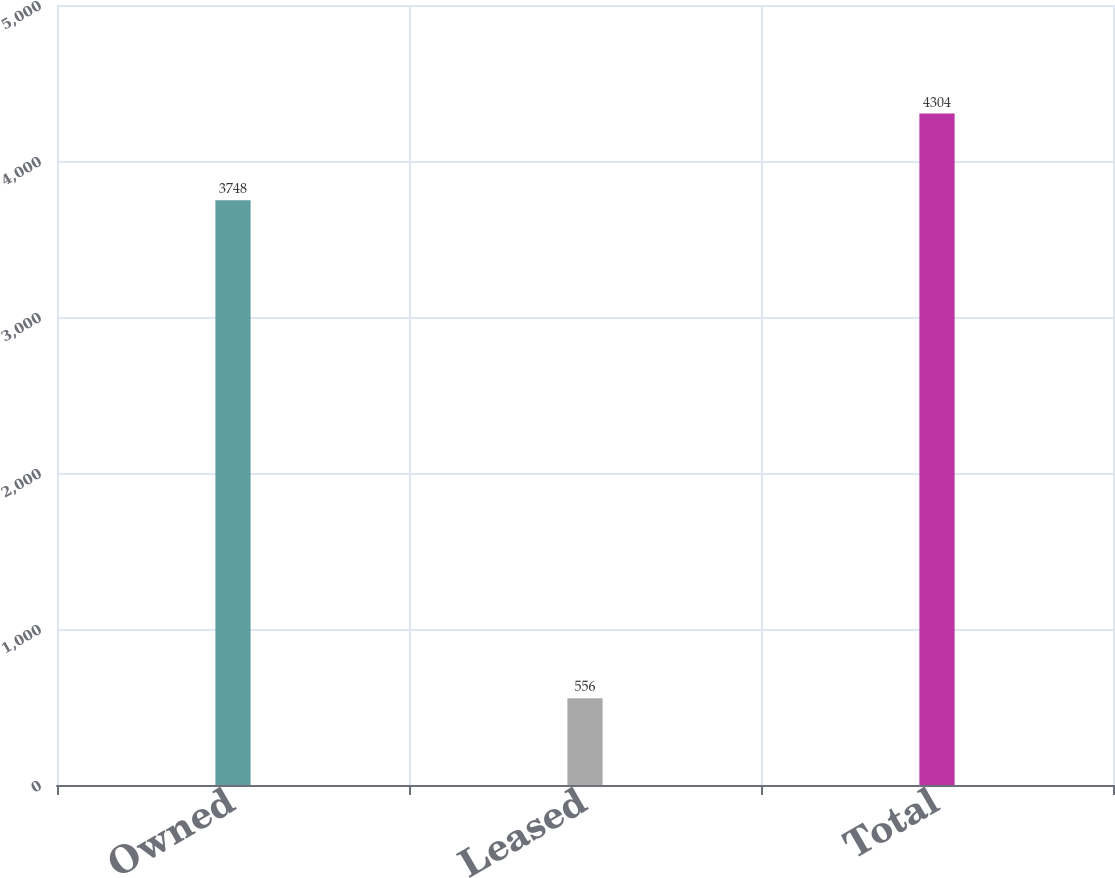<chart> <loc_0><loc_0><loc_500><loc_500><bar_chart><fcel>Owned<fcel>Leased<fcel>Total<nl><fcel>3748<fcel>556<fcel>4304<nl></chart> 